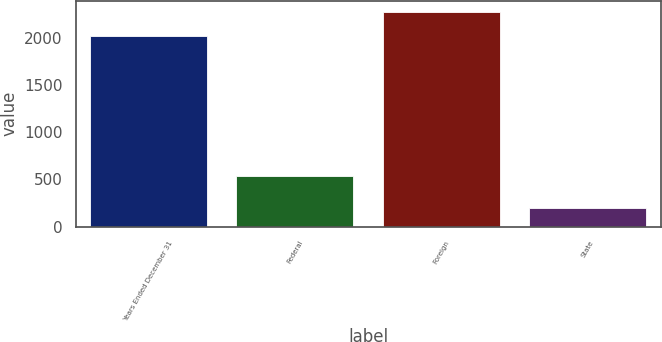Convert chart. <chart><loc_0><loc_0><loc_500><loc_500><bar_chart><fcel>Years Ended December 31<fcel>Federal<fcel>Foreign<fcel>State<nl><fcel>2018<fcel>536<fcel>2281<fcel>200<nl></chart> 